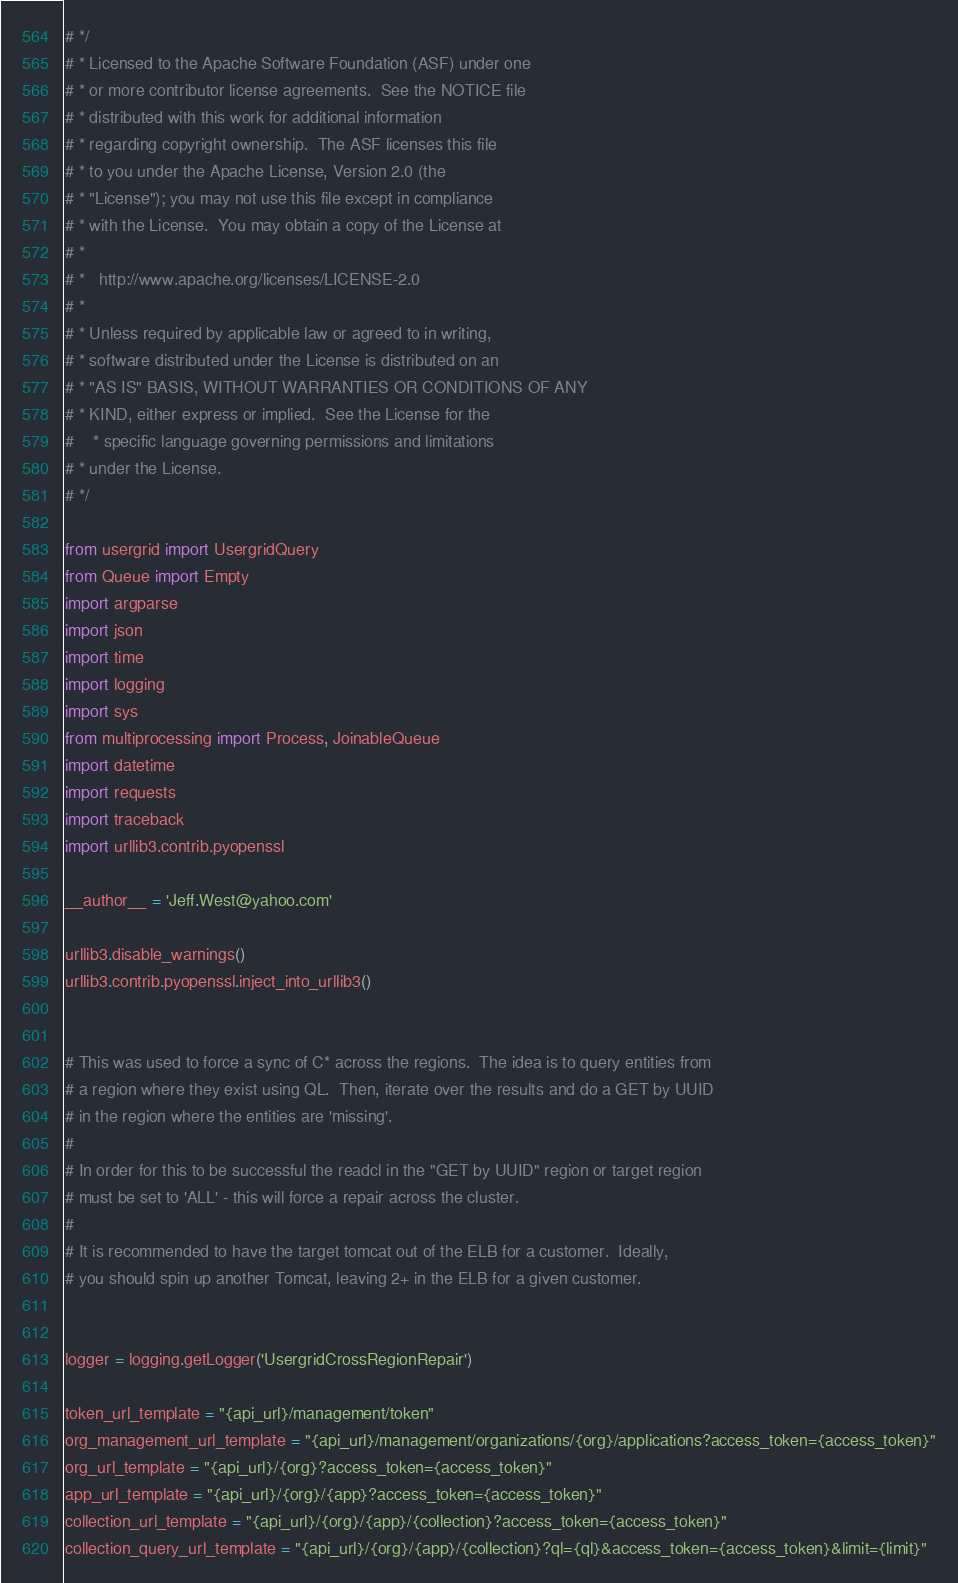Convert code to text. <code><loc_0><loc_0><loc_500><loc_500><_Python_># */
# * Licensed to the Apache Software Foundation (ASF) under one
# * or more contributor license agreements.  See the NOTICE file
# * distributed with this work for additional information
# * regarding copyright ownership.  The ASF licenses this file
# * to you under the Apache License, Version 2.0 (the
# * "License"); you may not use this file except in compliance
# * with the License.  You may obtain a copy of the License at
# *
# *   http://www.apache.org/licenses/LICENSE-2.0
# *
# * Unless required by applicable law or agreed to in writing,
# * software distributed under the License is distributed on an
# * "AS IS" BASIS, WITHOUT WARRANTIES OR CONDITIONS OF ANY
# * KIND, either express or implied.  See the License for the
#    * specific language governing permissions and limitations
# * under the License.
# */

from usergrid import UsergridQuery
from Queue import Empty
import argparse
import json
import time
import logging
import sys
from multiprocessing import Process, JoinableQueue
import datetime
import requests
import traceback
import urllib3.contrib.pyopenssl

__author__ = 'Jeff.West@yahoo.com'

urllib3.disable_warnings()
urllib3.contrib.pyopenssl.inject_into_urllib3()


# This was used to force a sync of C* across the regions.  The idea is to query entities from
# a region where they exist using QL.  Then, iterate over the results and do a GET by UUID
# in the region where the entities are 'missing'.
#
# In order for this to be successful the readcl in the "GET by UUID" region or target region
# must be set to 'ALL' - this will force a repair across the cluster.
#
# It is recommended to have the target tomcat out of the ELB for a customer.  Ideally,
# you should spin up another Tomcat, leaving 2+ in the ELB for a given customer.


logger = logging.getLogger('UsergridCrossRegionRepair')

token_url_template = "{api_url}/management/token"
org_management_url_template = "{api_url}/management/organizations/{org}/applications?access_token={access_token}"
org_url_template = "{api_url}/{org}?access_token={access_token}"
app_url_template = "{api_url}/{org}/{app}?access_token={access_token}"
collection_url_template = "{api_url}/{org}/{app}/{collection}?access_token={access_token}"
collection_query_url_template = "{api_url}/{org}/{app}/{collection}?ql={ql}&access_token={access_token}&limit={limit}"</code> 